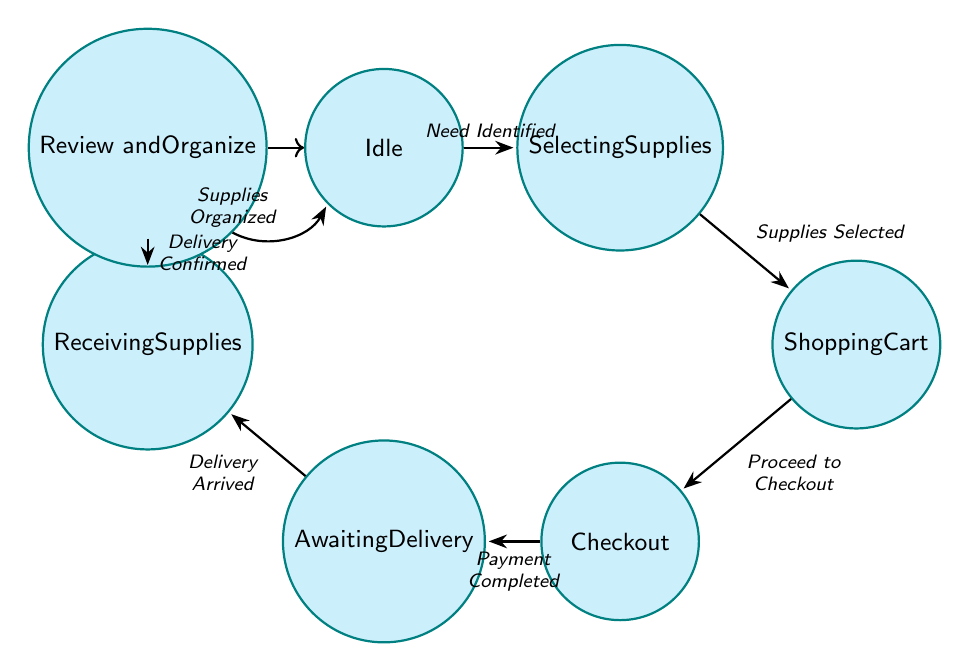What is the initial state of the diagram? The diagram starts in the 'Idle' state, which is indicated as the initial state at the beginning of the flow.
Answer: Idle How many total states are defined in the diagram? The diagram lists a total of 7 states: Idle, Selecting Supplies, Shopping Cart, Checkout, Awaiting Delivery, Receiving Supplies, and Review and Organize. Counting all of them gives 7.
Answer: 7 What triggers the transition from Selecting Supplies to Shopping Cart? The transition from 'Selecting Supplies' to 'Shopping Cart' is triggered by the event 'Supplies Selected', explicitly mentioned in the diagram's transitions.
Answer: Supplies Selected Which state follows Checkout? After the 'Checkout' state, the next state in the transition flow is 'Awaiting Delivery', as indicated by the direct connection between these two states.
Answer: Awaiting Delivery What is the final state after organizing supplies? After completing the organization of supplies, the flow returns to the 'Idle' state, indicating that the process can start anew.
Answer: Idle How many transitions are depicted in the diagram? The diagram shows a total of 6 transitions connecting the 7 states, as each transition is represented by a directed edge linking two states together.
Answer: 6 What action is required to move from Receiving Supplies to Review and Organize? The transition from 'Receiving Supplies' to 'Review and Organize' requires the action 'Delivery Confirmed', which is specified as the trigger for that transition.
Answer: Delivery Confirmed What is the purpose of the Idle state? The 'Idle' state is described as awaiting the need for new supplies, indicating that the process begins here when supplies are needed.
Answer: Awaiting the need for new supplies 